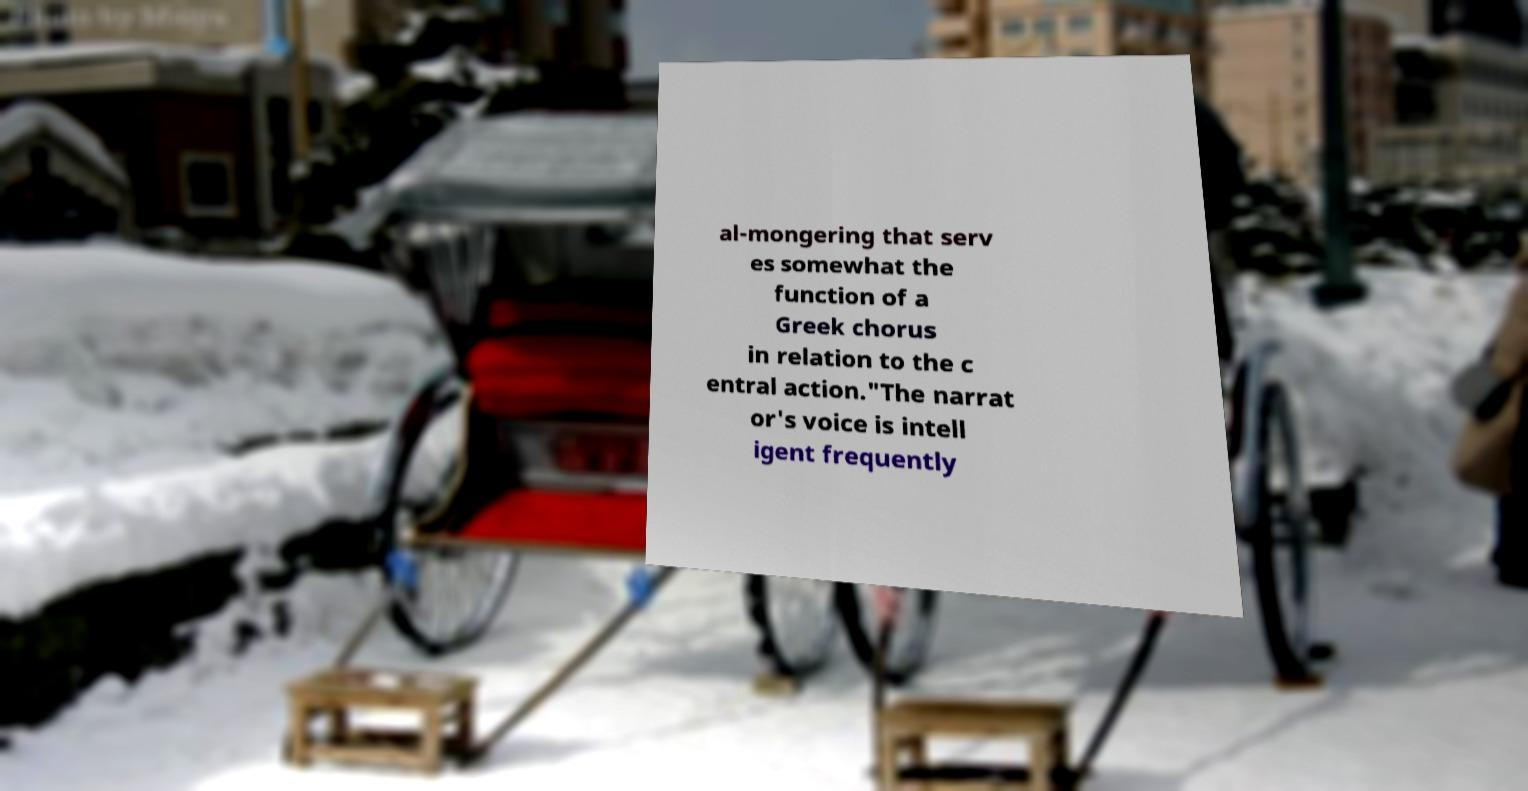Please read and relay the text visible in this image. What does it say? al-mongering that serv es somewhat the function of a Greek chorus in relation to the c entral action."The narrat or's voice is intell igent frequently 